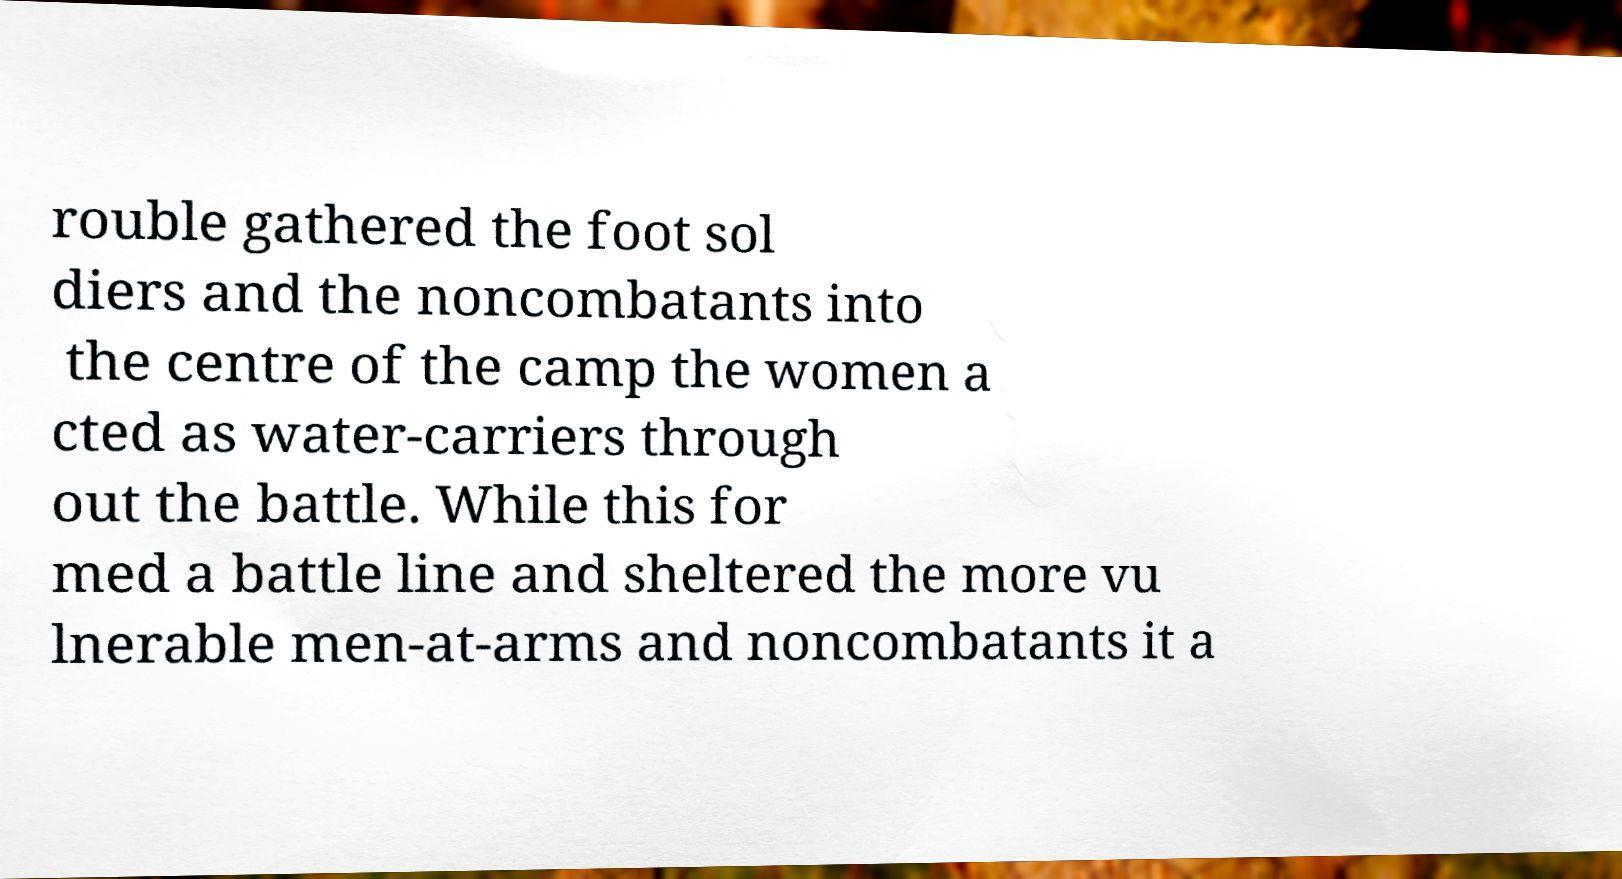For documentation purposes, I need the text within this image transcribed. Could you provide that? rouble gathered the foot sol diers and the noncombatants into the centre of the camp the women a cted as water-carriers through out the battle. While this for med a battle line and sheltered the more vu lnerable men-at-arms and noncombatants it a 